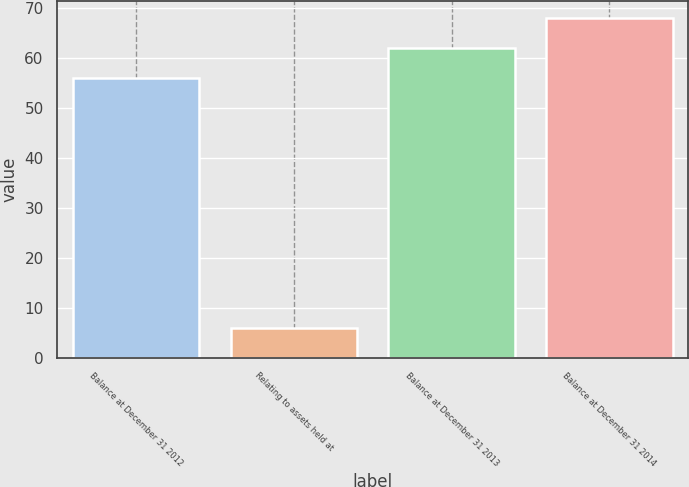Convert chart. <chart><loc_0><loc_0><loc_500><loc_500><bar_chart><fcel>Balance at December 31 2012<fcel>Relating to assets held at<fcel>Balance at December 31 2013<fcel>Balance at December 31 2014<nl><fcel>56<fcel>6<fcel>62<fcel>68<nl></chart> 